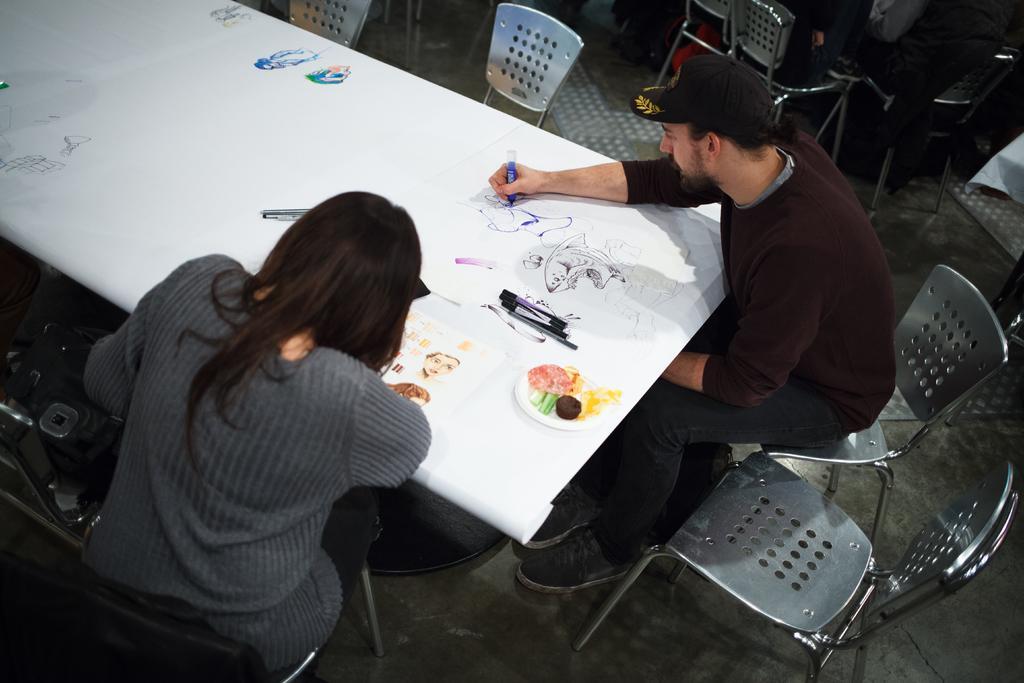Describe this image in one or two sentences. In the picture we can find one man and woman are sitting on the chairs in front of the table man is drawing something on the table and woman is seeing and man is wearing a cap. 